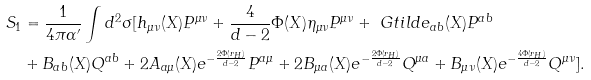Convert formula to latex. <formula><loc_0><loc_0><loc_500><loc_500>S _ { 1 } & = \frac { 1 } { 4 \pi \alpha ^ { \prime } } \int d ^ { 2 } \sigma [ h _ { \mu \nu } ( X ) P ^ { \mu \nu } + \frac { 4 } { d - 2 } \Phi ( X ) \eta _ { \mu \nu } P ^ { \mu \nu } + \ G t i l d e _ { a b } ( X ) P ^ { a b } \\ & + B _ { a b } ( X ) Q ^ { a b } + 2 A _ { a \mu } ( X ) e ^ { - \frac { 2 \Phi ( r _ { H } ) } { d - 2 } } P ^ { a \mu } + 2 B _ { \mu a } ( X ) e ^ { - \frac { 2 \Phi ( r _ { H } ) } { d - 2 } } Q ^ { \mu a } + B _ { \mu \nu } ( X ) e ^ { - \frac { 4 \Phi ( r _ { H } ) } { d - 2 } } Q ^ { \mu \nu } ] .</formula> 